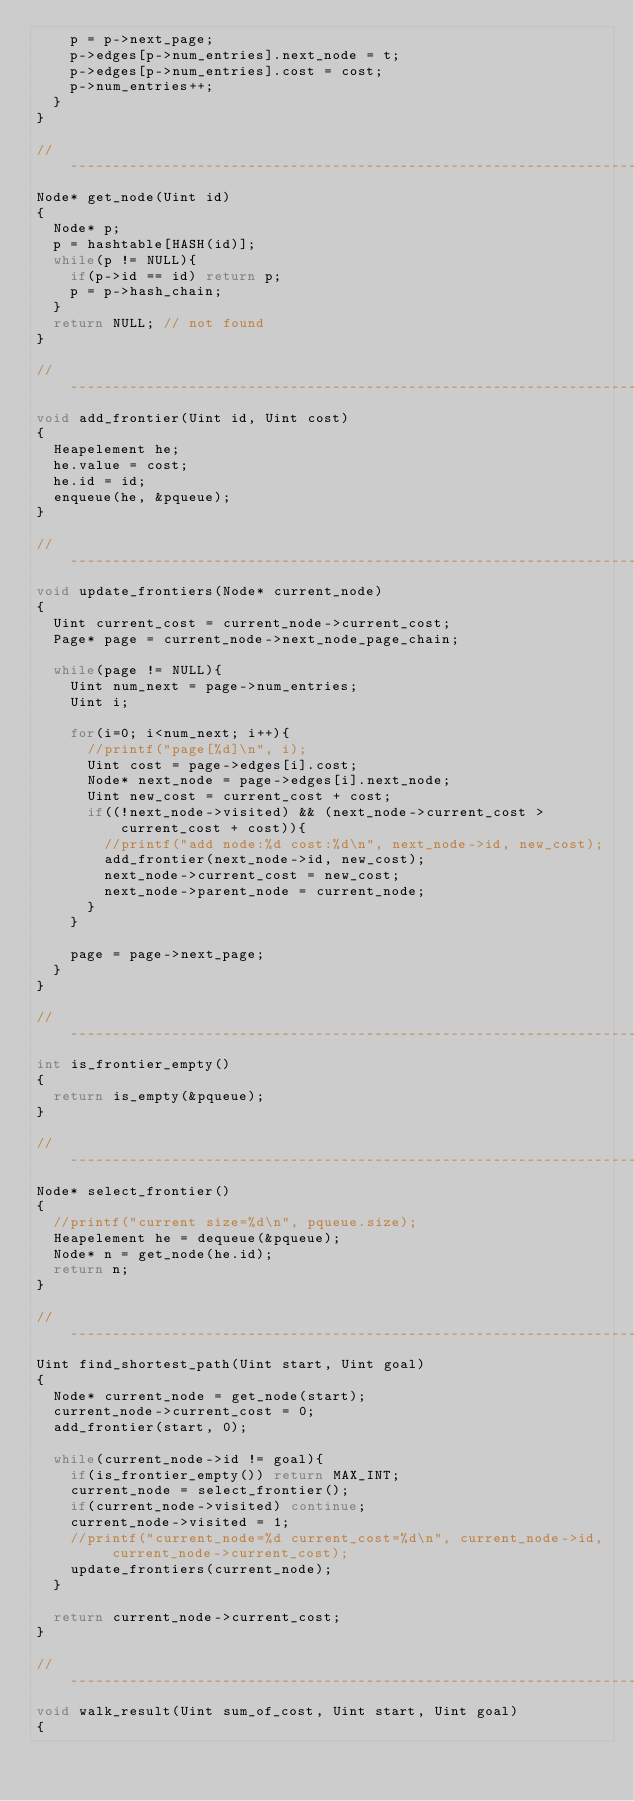<code> <loc_0><loc_0><loc_500><loc_500><_C_>    p = p->next_page;
    p->edges[p->num_entries].next_node = t;
    p->edges[p->num_entries].cost = cost;
    p->num_entries++;
  }
}

//------------------------------------------------------------------------------
Node* get_node(Uint id)
{
  Node* p;
  p = hashtable[HASH(id)];
  while(p != NULL){
    if(p->id == id) return p;
    p = p->hash_chain;
  }
  return NULL; // not found
}

//------------------------------------------------------------------------------
void add_frontier(Uint id, Uint cost)
{
  Heapelement he;
  he.value = cost;
  he.id = id;
  enqueue(he, &pqueue);
}

//------------------------------------------------------------------------------
void update_frontiers(Node* current_node)
{
  Uint current_cost = current_node->current_cost;
  Page* page = current_node->next_node_page_chain;

  while(page != NULL){
    Uint num_next = page->num_entries;
    Uint i;

    for(i=0; i<num_next; i++){
      //printf("page[%d]\n", i);
      Uint cost = page->edges[i].cost;
      Node* next_node = page->edges[i].next_node;
      Uint new_cost = current_cost + cost;
      if((!next_node->visited) && (next_node->current_cost > current_cost + cost)){
        //printf("add node:%d cost:%d\n", next_node->id, new_cost);
        add_frontier(next_node->id, new_cost);
        next_node->current_cost = new_cost;
        next_node->parent_node = current_node;
      }
    }
    
    page = page->next_page;
  }
}

//------------------------------------------------------------------------------
int is_frontier_empty()
{
  return is_empty(&pqueue);
}

//------------------------------------------------------------------------------
Node* select_frontier()
{
  //printf("current size=%d\n", pqueue.size);
  Heapelement he = dequeue(&pqueue);
  Node* n = get_node(he.id);
  return n;
}

//------------------------------------------------------------------------------
Uint find_shortest_path(Uint start, Uint goal)
{
  Node* current_node = get_node(start);
  current_node->current_cost = 0;
  add_frontier(start, 0);

  while(current_node->id != goal){
    if(is_frontier_empty()) return MAX_INT;
    current_node = select_frontier();
    if(current_node->visited) continue;
    current_node->visited = 1;
    //printf("current_node=%d current_cost=%d\n", current_node->id, current_node->current_cost);
    update_frontiers(current_node);
  }

  return current_node->current_cost;
}

//------------------------------------------------------------------------------
void walk_result(Uint sum_of_cost, Uint start, Uint goal)
{</code> 